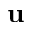Convert formula to latex. <formula><loc_0><loc_0><loc_500><loc_500>u</formula> 